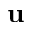Convert formula to latex. <formula><loc_0><loc_0><loc_500><loc_500>u</formula> 